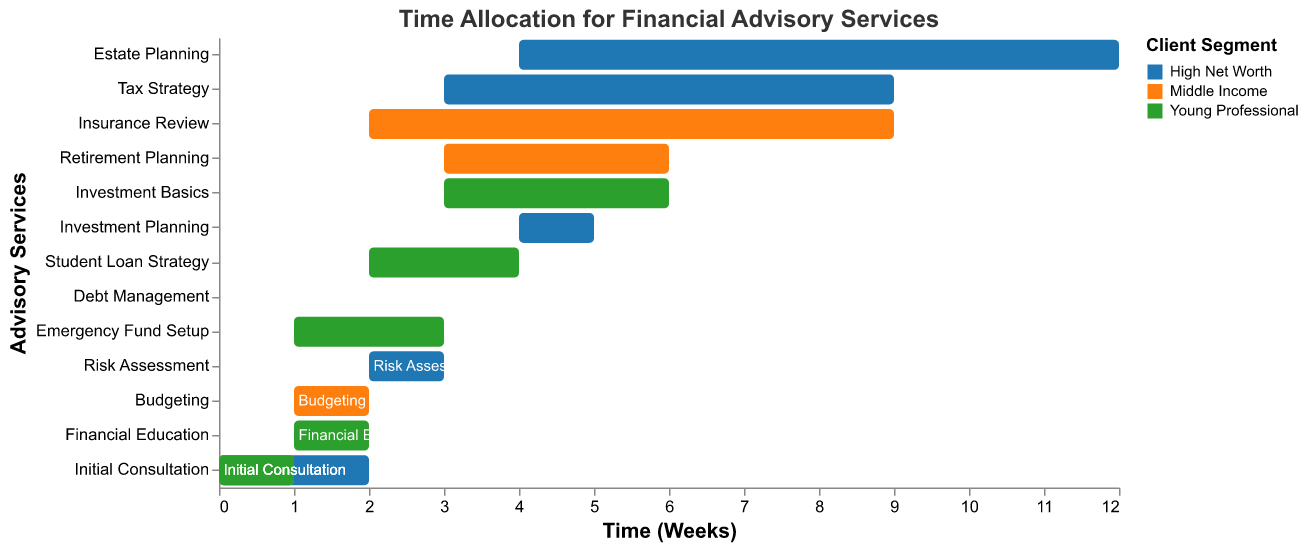What is the first task in the High Net Worth client segment? The Gantt Chart shows the time allocation for various tasks. For the High Net Worth segment, the initial task is "Initial Consultation" which starts at week 0.
Answer: Initial Consultation How long is the Debt Management task for the Middle Income segment? The Gantt Chart illustrates the duration of tasks. For the Middle Income segment, the "Debt Management" task starts at week 3 and has a duration of 3 weeks.
Answer: 3 weeks What color represents the Young Professional client segment? The Gantt Chart uses different colors to denote client segments. From the legend, the color for Young Professional is the third one, which is green.
Answer: Green Which task has the longest duration in the High Net Worth client segment? By inspecting the tasks under the High Net Worth segment and their durations, "Estate Planning" has the longest duration of 4 weeks.
Answer: Estate Planning Compare the total duration of advisory services between High Net Worth and Middle Income segments. Which is longer? Calculating the total duration for each segment: 
  High Net Worth: 2 + 3 + 4 + 3 + 4 = 16 weeks
  Middle Income: 1 + 2 + 3 + 3 + 2 = 11 weeks. Thus, High Net Worth has a longer total duration.
Answer: High Net Worth How many tasks are scheduled for the Young Professional client segment? By counting the tasks labeled under Young Professional, we see the tasks are: Initial Consultation, Financial Education, Emergency Fund Setup, Student Loan Strategy, and Investment Basics. This totals 5 tasks.
Answer: 5 tasks What is the start week and duration for the Emergency Fund Setup task in the Young Professional segment? The Gantt Chart shows that the "Emergency Fund Setup" task for the Young Professional segment starts at week 3 and lasts for 1 week.
Answer: Start at week 3, 1 week duration Which advisory service starts at week 1 for the Middle Income segment? According to the Gantt Chart, the task that starts at week 1 for the Middle Income segment is "Budgeting".
Answer: Budgeting List all tasks that start on week 0 across all client segments. From the chart, the tasks that start at week 0 are:
  - Initial Consultation (High Net Worth)
  - Initial Consultation (Middle Income)
  - Initial Consultation (Young Professional)
Answer: Initial Consultation (High Net Worth), Initial Consultation (Middle Income), Initial Consultation (Young Professional) Combine the durations of all tax-related tasks across each client segment. Only the High Net Worth segment has a tax-related task: "Tax Strategy" with a duration of 3 weeks. Other segments do not have tax-related tasks.
Answer: 3 weeks 